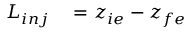<formula> <loc_0><loc_0><loc_500><loc_500>\begin{array} { r l } { L _ { i n j } } & = z _ { i e } - z _ { f e } } \end{array}</formula> 